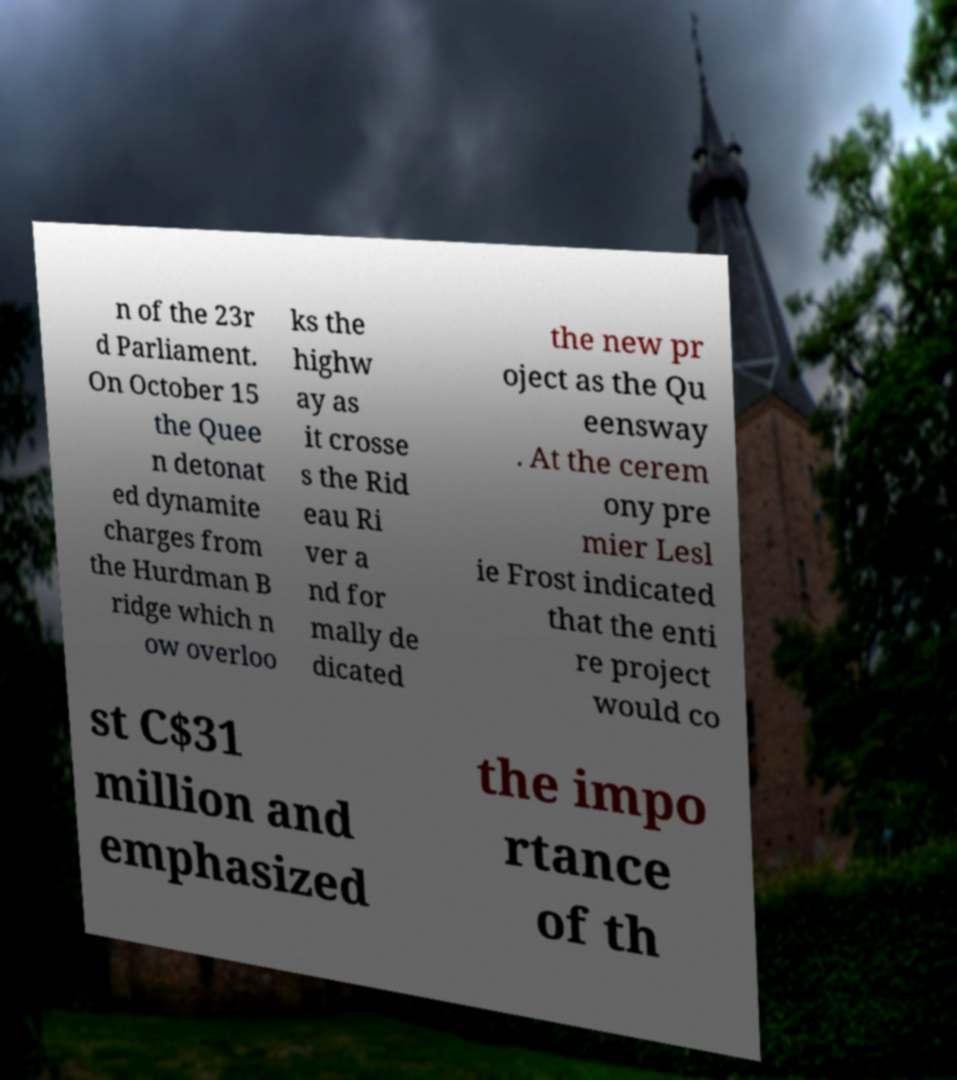What messages or text are displayed in this image? I need them in a readable, typed format. n of the 23r d Parliament. On October 15 the Quee n detonat ed dynamite charges from the Hurdman B ridge which n ow overloo ks the highw ay as it crosse s the Rid eau Ri ver a nd for mally de dicated the new pr oject as the Qu eensway . At the cerem ony pre mier Lesl ie Frost indicated that the enti re project would co st C$31 million and emphasized the impo rtance of th 